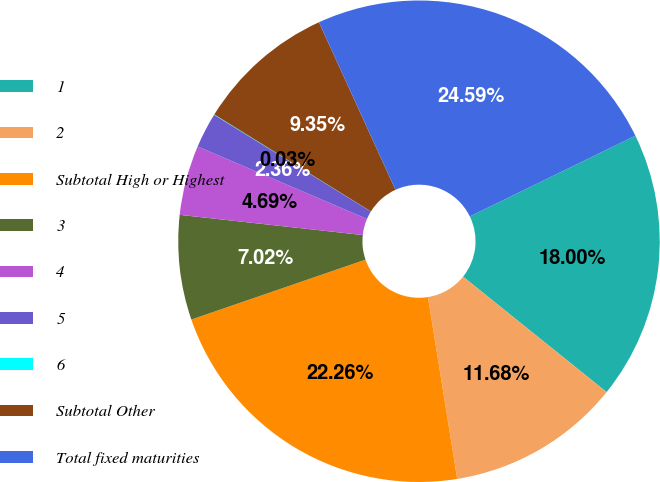Convert chart to OTSL. <chart><loc_0><loc_0><loc_500><loc_500><pie_chart><fcel>1<fcel>2<fcel>Subtotal High or Highest<fcel>3<fcel>4<fcel>5<fcel>6<fcel>Subtotal Other<fcel>Total fixed maturities<nl><fcel>18.0%<fcel>11.68%<fcel>22.26%<fcel>7.02%<fcel>4.69%<fcel>2.36%<fcel>0.03%<fcel>9.35%<fcel>24.59%<nl></chart> 